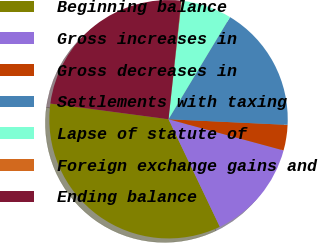Convert chart. <chart><loc_0><loc_0><loc_500><loc_500><pie_chart><fcel>Beginning balance<fcel>Gross increases in<fcel>Gross decreases in<fcel>Settlements with taxing<fcel>Lapse of statute of<fcel>Foreign exchange gains and<fcel>Ending balance<nl><fcel>34.18%<fcel>13.7%<fcel>3.46%<fcel>17.12%<fcel>6.88%<fcel>0.05%<fcel>24.6%<nl></chart> 